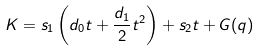<formula> <loc_0><loc_0><loc_500><loc_500>K = s _ { 1 } \left ( d _ { 0 } t + \frac { d _ { 1 } } { 2 } t ^ { 2 } \right ) + s _ { 2 } t + G ( q )</formula> 